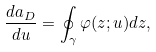Convert formula to latex. <formula><loc_0><loc_0><loc_500><loc_500>\frac { d a _ { D } } { d u } = \oint _ { \gamma } \varphi ( z ; u ) d z ,</formula> 